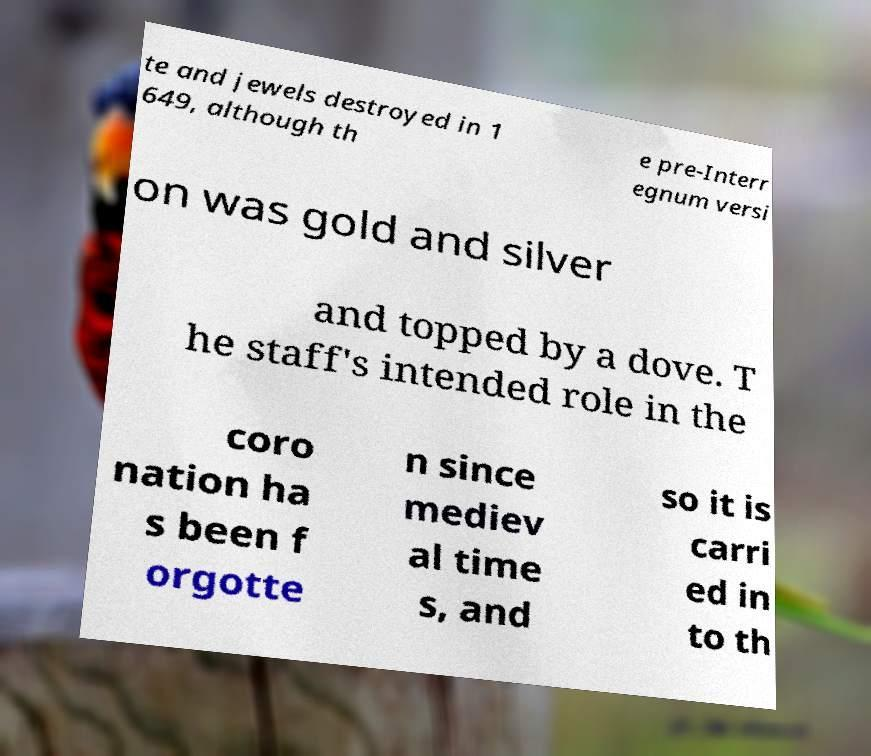Can you accurately transcribe the text from the provided image for me? te and jewels destroyed in 1 649, although th e pre-Interr egnum versi on was gold and silver and topped by a dove. T he staff's intended role in the coro nation ha s been f orgotte n since mediev al time s, and so it is carri ed in to th 